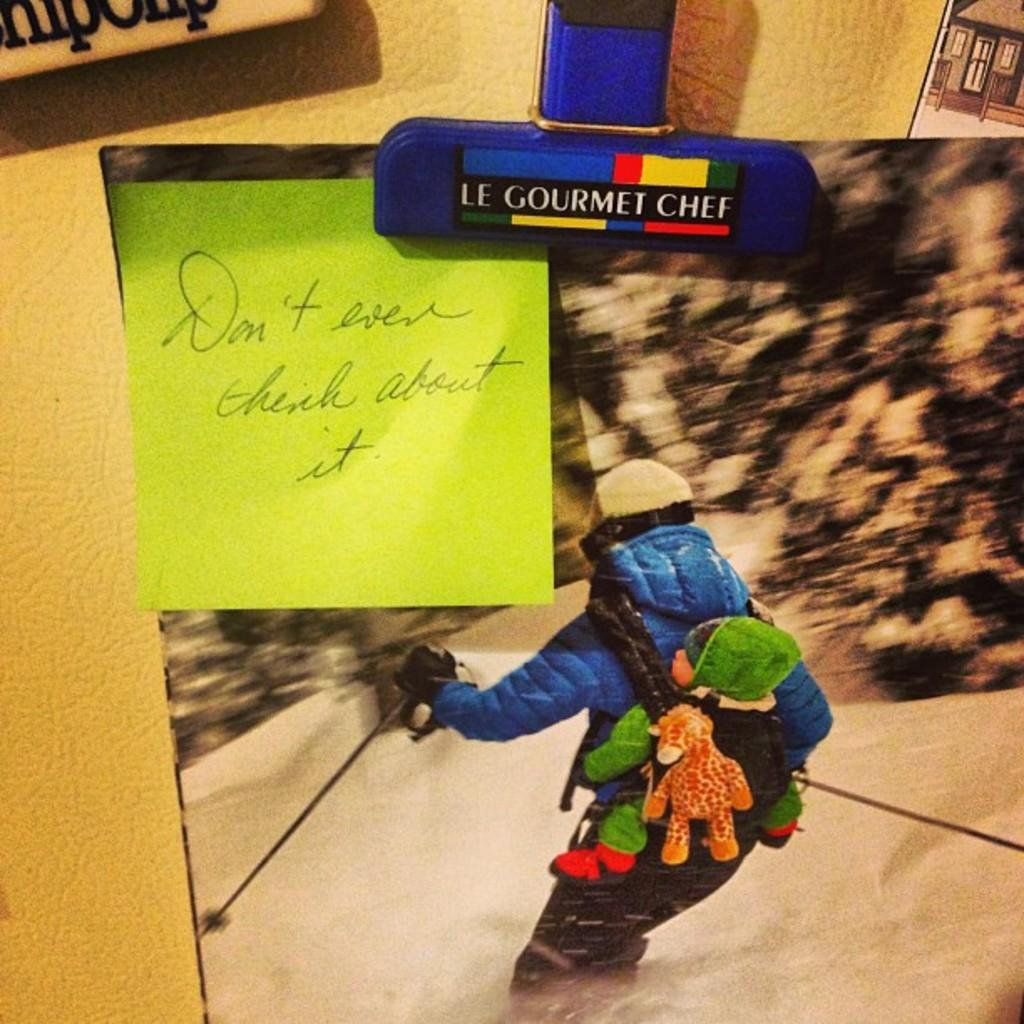What is the main subject of the image? There is a photograph in the image. What other items can be seen in the image? There are sticky notes in the image. Where are the photograph and sticky notes located? The photograph and sticky notes are placed on a wall. What type of vegetable is being cut by the knife on the photograph? There is no knife or vegetable present in the image; it only features a photograph and sticky notes on a wall. 